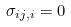<formula> <loc_0><loc_0><loc_500><loc_500>\sigma _ { i j , i } = 0</formula> 